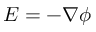<formula> <loc_0><loc_0><loc_500><loc_500>E = - \nabla \phi</formula> 